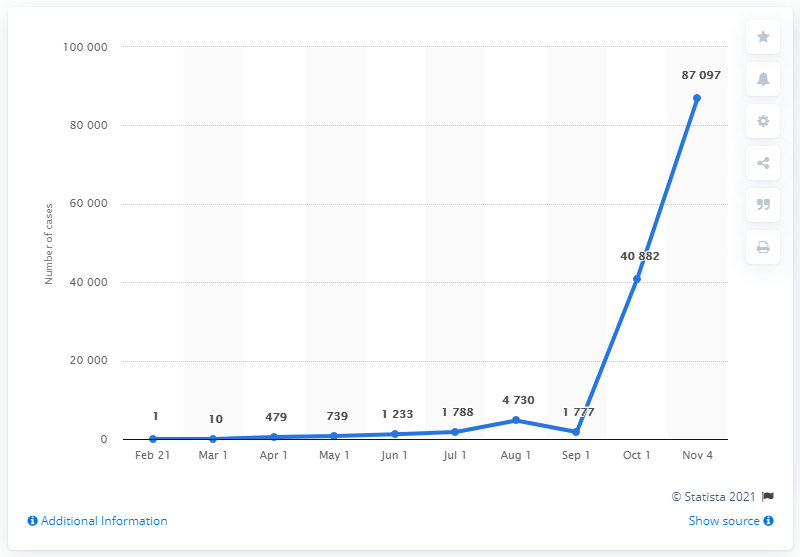Draw attention to some important aspects in this diagram. As of November 4, 2020, there have been a total of 87,097 cases of COVID-19 in Lebanon. 